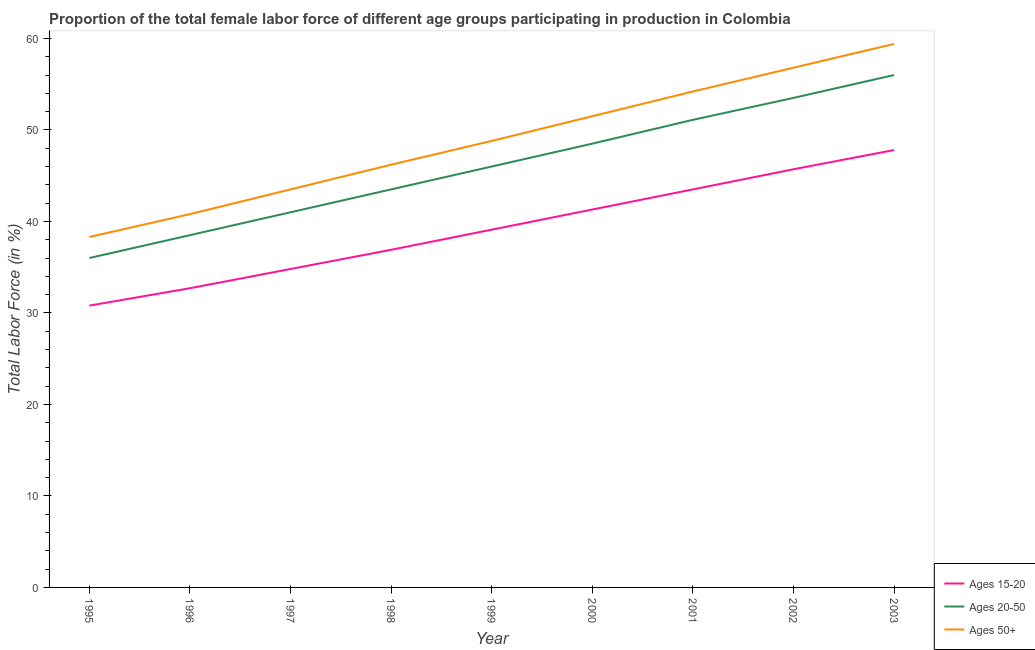How many different coloured lines are there?
Make the answer very short. 3. Is the number of lines equal to the number of legend labels?
Your answer should be compact. Yes. What is the percentage of female labor force within the age group 15-20 in 2001?
Offer a very short reply. 43.5. Across all years, what is the maximum percentage of female labor force within the age group 15-20?
Keep it short and to the point. 47.8. Across all years, what is the minimum percentage of female labor force within the age group 15-20?
Keep it short and to the point. 30.8. What is the total percentage of female labor force within the age group 15-20 in the graph?
Give a very brief answer. 352.6. What is the difference between the percentage of female labor force within the age group 20-50 in 1995 and that in 2003?
Provide a succinct answer. -20. What is the difference between the percentage of female labor force within the age group 20-50 in 1997 and the percentage of female labor force within the age group 15-20 in 1998?
Your answer should be compact. 4.1. What is the average percentage of female labor force within the age group 15-20 per year?
Provide a short and direct response. 39.18. In the year 2001, what is the difference between the percentage of female labor force within the age group 20-50 and percentage of female labor force within the age group 15-20?
Provide a short and direct response. 7.6. What is the ratio of the percentage of female labor force within the age group 20-50 in 1996 to that in 2001?
Make the answer very short. 0.75. Is the percentage of female labor force within the age group 20-50 in 1997 less than that in 1999?
Give a very brief answer. Yes. Is the difference between the percentage of female labor force above age 50 in 1997 and 2003 greater than the difference between the percentage of female labor force within the age group 15-20 in 1997 and 2003?
Your answer should be very brief. No. What is the difference between the highest and the lowest percentage of female labor force within the age group 15-20?
Ensure brevity in your answer.  17. Is it the case that in every year, the sum of the percentage of female labor force within the age group 15-20 and percentage of female labor force within the age group 20-50 is greater than the percentage of female labor force above age 50?
Keep it short and to the point. Yes. Does the percentage of female labor force within the age group 20-50 monotonically increase over the years?
Provide a short and direct response. Yes. Is the percentage of female labor force within the age group 15-20 strictly less than the percentage of female labor force above age 50 over the years?
Offer a terse response. Yes. How many lines are there?
Your answer should be compact. 3. How many years are there in the graph?
Keep it short and to the point. 9. What is the difference between two consecutive major ticks on the Y-axis?
Your answer should be compact. 10. Are the values on the major ticks of Y-axis written in scientific E-notation?
Offer a terse response. No. Where does the legend appear in the graph?
Provide a short and direct response. Bottom right. How are the legend labels stacked?
Offer a terse response. Vertical. What is the title of the graph?
Ensure brevity in your answer.  Proportion of the total female labor force of different age groups participating in production in Colombia. What is the label or title of the Y-axis?
Provide a succinct answer. Total Labor Force (in %). What is the Total Labor Force (in %) of Ages 15-20 in 1995?
Keep it short and to the point. 30.8. What is the Total Labor Force (in %) in Ages 20-50 in 1995?
Offer a terse response. 36. What is the Total Labor Force (in %) of Ages 50+ in 1995?
Provide a short and direct response. 38.3. What is the Total Labor Force (in %) of Ages 15-20 in 1996?
Your response must be concise. 32.7. What is the Total Labor Force (in %) in Ages 20-50 in 1996?
Give a very brief answer. 38.5. What is the Total Labor Force (in %) in Ages 50+ in 1996?
Your response must be concise. 40.8. What is the Total Labor Force (in %) in Ages 15-20 in 1997?
Your answer should be very brief. 34.8. What is the Total Labor Force (in %) of Ages 20-50 in 1997?
Provide a succinct answer. 41. What is the Total Labor Force (in %) in Ages 50+ in 1997?
Your answer should be very brief. 43.5. What is the Total Labor Force (in %) of Ages 15-20 in 1998?
Provide a succinct answer. 36.9. What is the Total Labor Force (in %) of Ages 20-50 in 1998?
Ensure brevity in your answer.  43.5. What is the Total Labor Force (in %) in Ages 50+ in 1998?
Give a very brief answer. 46.2. What is the Total Labor Force (in %) in Ages 15-20 in 1999?
Ensure brevity in your answer.  39.1. What is the Total Labor Force (in %) of Ages 20-50 in 1999?
Give a very brief answer. 46. What is the Total Labor Force (in %) of Ages 50+ in 1999?
Make the answer very short. 48.8. What is the Total Labor Force (in %) in Ages 15-20 in 2000?
Your answer should be very brief. 41.3. What is the Total Labor Force (in %) in Ages 20-50 in 2000?
Make the answer very short. 48.5. What is the Total Labor Force (in %) of Ages 50+ in 2000?
Make the answer very short. 51.5. What is the Total Labor Force (in %) of Ages 15-20 in 2001?
Your answer should be very brief. 43.5. What is the Total Labor Force (in %) in Ages 20-50 in 2001?
Provide a succinct answer. 51.1. What is the Total Labor Force (in %) in Ages 50+ in 2001?
Your answer should be very brief. 54.2. What is the Total Labor Force (in %) of Ages 15-20 in 2002?
Offer a terse response. 45.7. What is the Total Labor Force (in %) in Ages 20-50 in 2002?
Your answer should be compact. 53.5. What is the Total Labor Force (in %) of Ages 50+ in 2002?
Your response must be concise. 56.8. What is the Total Labor Force (in %) in Ages 15-20 in 2003?
Your answer should be very brief. 47.8. What is the Total Labor Force (in %) of Ages 20-50 in 2003?
Keep it short and to the point. 56. What is the Total Labor Force (in %) in Ages 50+ in 2003?
Make the answer very short. 59.4. Across all years, what is the maximum Total Labor Force (in %) in Ages 15-20?
Your answer should be very brief. 47.8. Across all years, what is the maximum Total Labor Force (in %) of Ages 50+?
Keep it short and to the point. 59.4. Across all years, what is the minimum Total Labor Force (in %) in Ages 15-20?
Make the answer very short. 30.8. Across all years, what is the minimum Total Labor Force (in %) of Ages 50+?
Offer a terse response. 38.3. What is the total Total Labor Force (in %) in Ages 15-20 in the graph?
Your response must be concise. 352.6. What is the total Total Labor Force (in %) of Ages 20-50 in the graph?
Your response must be concise. 414.1. What is the total Total Labor Force (in %) of Ages 50+ in the graph?
Offer a very short reply. 439.5. What is the difference between the Total Labor Force (in %) in Ages 15-20 in 1995 and that in 1996?
Give a very brief answer. -1.9. What is the difference between the Total Labor Force (in %) of Ages 20-50 in 1995 and that in 1996?
Your answer should be compact. -2.5. What is the difference between the Total Labor Force (in %) of Ages 20-50 in 1995 and that in 1997?
Your answer should be very brief. -5. What is the difference between the Total Labor Force (in %) in Ages 20-50 in 1995 and that in 2001?
Provide a succinct answer. -15.1. What is the difference between the Total Labor Force (in %) of Ages 50+ in 1995 and that in 2001?
Give a very brief answer. -15.9. What is the difference between the Total Labor Force (in %) in Ages 15-20 in 1995 and that in 2002?
Keep it short and to the point. -14.9. What is the difference between the Total Labor Force (in %) in Ages 20-50 in 1995 and that in 2002?
Make the answer very short. -17.5. What is the difference between the Total Labor Force (in %) in Ages 50+ in 1995 and that in 2002?
Give a very brief answer. -18.5. What is the difference between the Total Labor Force (in %) in Ages 20-50 in 1995 and that in 2003?
Your answer should be very brief. -20. What is the difference between the Total Labor Force (in %) of Ages 50+ in 1995 and that in 2003?
Your response must be concise. -21.1. What is the difference between the Total Labor Force (in %) of Ages 15-20 in 1996 and that in 1997?
Offer a terse response. -2.1. What is the difference between the Total Labor Force (in %) of Ages 50+ in 1996 and that in 1997?
Offer a terse response. -2.7. What is the difference between the Total Labor Force (in %) in Ages 15-20 in 1996 and that in 1998?
Offer a terse response. -4.2. What is the difference between the Total Labor Force (in %) of Ages 50+ in 1996 and that in 1998?
Give a very brief answer. -5.4. What is the difference between the Total Labor Force (in %) of Ages 20-50 in 1996 and that in 1999?
Make the answer very short. -7.5. What is the difference between the Total Labor Force (in %) in Ages 15-20 in 1996 and that in 2000?
Your response must be concise. -8.6. What is the difference between the Total Labor Force (in %) of Ages 50+ in 1996 and that in 2000?
Give a very brief answer. -10.7. What is the difference between the Total Labor Force (in %) in Ages 15-20 in 1996 and that in 2002?
Keep it short and to the point. -13. What is the difference between the Total Labor Force (in %) in Ages 15-20 in 1996 and that in 2003?
Your answer should be very brief. -15.1. What is the difference between the Total Labor Force (in %) of Ages 20-50 in 1996 and that in 2003?
Your answer should be compact. -17.5. What is the difference between the Total Labor Force (in %) in Ages 50+ in 1996 and that in 2003?
Your answer should be compact. -18.6. What is the difference between the Total Labor Force (in %) in Ages 20-50 in 1997 and that in 1998?
Ensure brevity in your answer.  -2.5. What is the difference between the Total Labor Force (in %) of Ages 50+ in 1997 and that in 1998?
Your response must be concise. -2.7. What is the difference between the Total Labor Force (in %) of Ages 20-50 in 1997 and that in 1999?
Provide a succinct answer. -5. What is the difference between the Total Labor Force (in %) in Ages 15-20 in 1997 and that in 2001?
Provide a succinct answer. -8.7. What is the difference between the Total Labor Force (in %) of Ages 20-50 in 1997 and that in 2001?
Ensure brevity in your answer.  -10.1. What is the difference between the Total Labor Force (in %) in Ages 15-20 in 1997 and that in 2002?
Keep it short and to the point. -10.9. What is the difference between the Total Labor Force (in %) in Ages 20-50 in 1997 and that in 2002?
Keep it short and to the point. -12.5. What is the difference between the Total Labor Force (in %) of Ages 50+ in 1997 and that in 2002?
Your answer should be very brief. -13.3. What is the difference between the Total Labor Force (in %) of Ages 20-50 in 1997 and that in 2003?
Ensure brevity in your answer.  -15. What is the difference between the Total Labor Force (in %) of Ages 50+ in 1997 and that in 2003?
Ensure brevity in your answer.  -15.9. What is the difference between the Total Labor Force (in %) of Ages 15-20 in 1998 and that in 1999?
Provide a short and direct response. -2.2. What is the difference between the Total Labor Force (in %) in Ages 50+ in 1998 and that in 1999?
Give a very brief answer. -2.6. What is the difference between the Total Labor Force (in %) of Ages 15-20 in 1998 and that in 2000?
Your response must be concise. -4.4. What is the difference between the Total Labor Force (in %) of Ages 20-50 in 1998 and that in 2000?
Offer a very short reply. -5. What is the difference between the Total Labor Force (in %) of Ages 50+ in 1998 and that in 2001?
Offer a terse response. -8. What is the difference between the Total Labor Force (in %) of Ages 20-50 in 1998 and that in 2002?
Give a very brief answer. -10. What is the difference between the Total Labor Force (in %) in Ages 15-20 in 1998 and that in 2003?
Your answer should be compact. -10.9. What is the difference between the Total Labor Force (in %) in Ages 20-50 in 1998 and that in 2003?
Offer a terse response. -12.5. What is the difference between the Total Labor Force (in %) of Ages 15-20 in 1999 and that in 2000?
Ensure brevity in your answer.  -2.2. What is the difference between the Total Labor Force (in %) of Ages 50+ in 1999 and that in 2001?
Your answer should be compact. -5.4. What is the difference between the Total Labor Force (in %) in Ages 15-20 in 1999 and that in 2002?
Ensure brevity in your answer.  -6.6. What is the difference between the Total Labor Force (in %) of Ages 20-50 in 1999 and that in 2002?
Keep it short and to the point. -7.5. What is the difference between the Total Labor Force (in %) in Ages 50+ in 1999 and that in 2002?
Give a very brief answer. -8. What is the difference between the Total Labor Force (in %) of Ages 15-20 in 1999 and that in 2003?
Your answer should be compact. -8.7. What is the difference between the Total Labor Force (in %) in Ages 20-50 in 1999 and that in 2003?
Your answer should be very brief. -10. What is the difference between the Total Labor Force (in %) in Ages 50+ in 1999 and that in 2003?
Offer a very short reply. -10.6. What is the difference between the Total Labor Force (in %) in Ages 15-20 in 2000 and that in 2001?
Keep it short and to the point. -2.2. What is the difference between the Total Labor Force (in %) in Ages 50+ in 2000 and that in 2001?
Offer a terse response. -2.7. What is the difference between the Total Labor Force (in %) in Ages 20-50 in 2000 and that in 2002?
Offer a very short reply. -5. What is the difference between the Total Labor Force (in %) in Ages 15-20 in 2000 and that in 2003?
Ensure brevity in your answer.  -6.5. What is the difference between the Total Labor Force (in %) of Ages 50+ in 2000 and that in 2003?
Provide a succinct answer. -7.9. What is the difference between the Total Labor Force (in %) in Ages 15-20 in 2001 and that in 2002?
Your answer should be compact. -2.2. What is the difference between the Total Labor Force (in %) of Ages 15-20 in 2001 and that in 2003?
Keep it short and to the point. -4.3. What is the difference between the Total Labor Force (in %) in Ages 15-20 in 2002 and that in 2003?
Ensure brevity in your answer.  -2.1. What is the difference between the Total Labor Force (in %) of Ages 50+ in 2002 and that in 2003?
Provide a succinct answer. -2.6. What is the difference between the Total Labor Force (in %) in Ages 15-20 in 1995 and the Total Labor Force (in %) in Ages 20-50 in 1996?
Make the answer very short. -7.7. What is the difference between the Total Labor Force (in %) of Ages 20-50 in 1995 and the Total Labor Force (in %) of Ages 50+ in 1996?
Your answer should be very brief. -4.8. What is the difference between the Total Labor Force (in %) of Ages 15-20 in 1995 and the Total Labor Force (in %) of Ages 20-50 in 1997?
Your answer should be compact. -10.2. What is the difference between the Total Labor Force (in %) in Ages 15-20 in 1995 and the Total Labor Force (in %) in Ages 50+ in 1997?
Offer a very short reply. -12.7. What is the difference between the Total Labor Force (in %) of Ages 15-20 in 1995 and the Total Labor Force (in %) of Ages 20-50 in 1998?
Your answer should be very brief. -12.7. What is the difference between the Total Labor Force (in %) of Ages 15-20 in 1995 and the Total Labor Force (in %) of Ages 50+ in 1998?
Give a very brief answer. -15.4. What is the difference between the Total Labor Force (in %) in Ages 20-50 in 1995 and the Total Labor Force (in %) in Ages 50+ in 1998?
Offer a very short reply. -10.2. What is the difference between the Total Labor Force (in %) in Ages 15-20 in 1995 and the Total Labor Force (in %) in Ages 20-50 in 1999?
Provide a short and direct response. -15.2. What is the difference between the Total Labor Force (in %) of Ages 15-20 in 1995 and the Total Labor Force (in %) of Ages 20-50 in 2000?
Keep it short and to the point. -17.7. What is the difference between the Total Labor Force (in %) of Ages 15-20 in 1995 and the Total Labor Force (in %) of Ages 50+ in 2000?
Your response must be concise. -20.7. What is the difference between the Total Labor Force (in %) in Ages 20-50 in 1995 and the Total Labor Force (in %) in Ages 50+ in 2000?
Offer a very short reply. -15.5. What is the difference between the Total Labor Force (in %) in Ages 15-20 in 1995 and the Total Labor Force (in %) in Ages 20-50 in 2001?
Your response must be concise. -20.3. What is the difference between the Total Labor Force (in %) in Ages 15-20 in 1995 and the Total Labor Force (in %) in Ages 50+ in 2001?
Provide a succinct answer. -23.4. What is the difference between the Total Labor Force (in %) of Ages 20-50 in 1995 and the Total Labor Force (in %) of Ages 50+ in 2001?
Offer a very short reply. -18.2. What is the difference between the Total Labor Force (in %) of Ages 15-20 in 1995 and the Total Labor Force (in %) of Ages 20-50 in 2002?
Make the answer very short. -22.7. What is the difference between the Total Labor Force (in %) of Ages 20-50 in 1995 and the Total Labor Force (in %) of Ages 50+ in 2002?
Your answer should be very brief. -20.8. What is the difference between the Total Labor Force (in %) in Ages 15-20 in 1995 and the Total Labor Force (in %) in Ages 20-50 in 2003?
Give a very brief answer. -25.2. What is the difference between the Total Labor Force (in %) in Ages 15-20 in 1995 and the Total Labor Force (in %) in Ages 50+ in 2003?
Ensure brevity in your answer.  -28.6. What is the difference between the Total Labor Force (in %) in Ages 20-50 in 1995 and the Total Labor Force (in %) in Ages 50+ in 2003?
Keep it short and to the point. -23.4. What is the difference between the Total Labor Force (in %) in Ages 15-20 in 1996 and the Total Labor Force (in %) in Ages 20-50 in 1997?
Offer a very short reply. -8.3. What is the difference between the Total Labor Force (in %) in Ages 15-20 in 1996 and the Total Labor Force (in %) in Ages 50+ in 1997?
Your answer should be very brief. -10.8. What is the difference between the Total Labor Force (in %) of Ages 20-50 in 1996 and the Total Labor Force (in %) of Ages 50+ in 1997?
Offer a very short reply. -5. What is the difference between the Total Labor Force (in %) in Ages 20-50 in 1996 and the Total Labor Force (in %) in Ages 50+ in 1998?
Ensure brevity in your answer.  -7.7. What is the difference between the Total Labor Force (in %) in Ages 15-20 in 1996 and the Total Labor Force (in %) in Ages 50+ in 1999?
Ensure brevity in your answer.  -16.1. What is the difference between the Total Labor Force (in %) in Ages 20-50 in 1996 and the Total Labor Force (in %) in Ages 50+ in 1999?
Your answer should be very brief. -10.3. What is the difference between the Total Labor Force (in %) of Ages 15-20 in 1996 and the Total Labor Force (in %) of Ages 20-50 in 2000?
Offer a very short reply. -15.8. What is the difference between the Total Labor Force (in %) of Ages 15-20 in 1996 and the Total Labor Force (in %) of Ages 50+ in 2000?
Give a very brief answer. -18.8. What is the difference between the Total Labor Force (in %) in Ages 20-50 in 1996 and the Total Labor Force (in %) in Ages 50+ in 2000?
Provide a succinct answer. -13. What is the difference between the Total Labor Force (in %) of Ages 15-20 in 1996 and the Total Labor Force (in %) of Ages 20-50 in 2001?
Provide a short and direct response. -18.4. What is the difference between the Total Labor Force (in %) of Ages 15-20 in 1996 and the Total Labor Force (in %) of Ages 50+ in 2001?
Keep it short and to the point. -21.5. What is the difference between the Total Labor Force (in %) of Ages 20-50 in 1996 and the Total Labor Force (in %) of Ages 50+ in 2001?
Give a very brief answer. -15.7. What is the difference between the Total Labor Force (in %) of Ages 15-20 in 1996 and the Total Labor Force (in %) of Ages 20-50 in 2002?
Give a very brief answer. -20.8. What is the difference between the Total Labor Force (in %) of Ages 15-20 in 1996 and the Total Labor Force (in %) of Ages 50+ in 2002?
Ensure brevity in your answer.  -24.1. What is the difference between the Total Labor Force (in %) of Ages 20-50 in 1996 and the Total Labor Force (in %) of Ages 50+ in 2002?
Your response must be concise. -18.3. What is the difference between the Total Labor Force (in %) in Ages 15-20 in 1996 and the Total Labor Force (in %) in Ages 20-50 in 2003?
Provide a succinct answer. -23.3. What is the difference between the Total Labor Force (in %) of Ages 15-20 in 1996 and the Total Labor Force (in %) of Ages 50+ in 2003?
Offer a terse response. -26.7. What is the difference between the Total Labor Force (in %) of Ages 20-50 in 1996 and the Total Labor Force (in %) of Ages 50+ in 2003?
Offer a terse response. -20.9. What is the difference between the Total Labor Force (in %) of Ages 15-20 in 1997 and the Total Labor Force (in %) of Ages 20-50 in 1999?
Your answer should be compact. -11.2. What is the difference between the Total Labor Force (in %) in Ages 15-20 in 1997 and the Total Labor Force (in %) in Ages 50+ in 1999?
Your answer should be very brief. -14. What is the difference between the Total Labor Force (in %) in Ages 20-50 in 1997 and the Total Labor Force (in %) in Ages 50+ in 1999?
Your answer should be very brief. -7.8. What is the difference between the Total Labor Force (in %) in Ages 15-20 in 1997 and the Total Labor Force (in %) in Ages 20-50 in 2000?
Provide a succinct answer. -13.7. What is the difference between the Total Labor Force (in %) of Ages 15-20 in 1997 and the Total Labor Force (in %) of Ages 50+ in 2000?
Your answer should be very brief. -16.7. What is the difference between the Total Labor Force (in %) of Ages 20-50 in 1997 and the Total Labor Force (in %) of Ages 50+ in 2000?
Offer a terse response. -10.5. What is the difference between the Total Labor Force (in %) in Ages 15-20 in 1997 and the Total Labor Force (in %) in Ages 20-50 in 2001?
Provide a short and direct response. -16.3. What is the difference between the Total Labor Force (in %) in Ages 15-20 in 1997 and the Total Labor Force (in %) in Ages 50+ in 2001?
Offer a terse response. -19.4. What is the difference between the Total Labor Force (in %) of Ages 15-20 in 1997 and the Total Labor Force (in %) of Ages 20-50 in 2002?
Your answer should be very brief. -18.7. What is the difference between the Total Labor Force (in %) of Ages 20-50 in 1997 and the Total Labor Force (in %) of Ages 50+ in 2002?
Provide a succinct answer. -15.8. What is the difference between the Total Labor Force (in %) of Ages 15-20 in 1997 and the Total Labor Force (in %) of Ages 20-50 in 2003?
Give a very brief answer. -21.2. What is the difference between the Total Labor Force (in %) in Ages 15-20 in 1997 and the Total Labor Force (in %) in Ages 50+ in 2003?
Ensure brevity in your answer.  -24.6. What is the difference between the Total Labor Force (in %) in Ages 20-50 in 1997 and the Total Labor Force (in %) in Ages 50+ in 2003?
Give a very brief answer. -18.4. What is the difference between the Total Labor Force (in %) in Ages 15-20 in 1998 and the Total Labor Force (in %) in Ages 20-50 in 1999?
Ensure brevity in your answer.  -9.1. What is the difference between the Total Labor Force (in %) of Ages 15-20 in 1998 and the Total Labor Force (in %) of Ages 50+ in 1999?
Your answer should be very brief. -11.9. What is the difference between the Total Labor Force (in %) of Ages 15-20 in 1998 and the Total Labor Force (in %) of Ages 50+ in 2000?
Give a very brief answer. -14.6. What is the difference between the Total Labor Force (in %) in Ages 15-20 in 1998 and the Total Labor Force (in %) in Ages 50+ in 2001?
Your response must be concise. -17.3. What is the difference between the Total Labor Force (in %) in Ages 20-50 in 1998 and the Total Labor Force (in %) in Ages 50+ in 2001?
Offer a very short reply. -10.7. What is the difference between the Total Labor Force (in %) in Ages 15-20 in 1998 and the Total Labor Force (in %) in Ages 20-50 in 2002?
Keep it short and to the point. -16.6. What is the difference between the Total Labor Force (in %) of Ages 15-20 in 1998 and the Total Labor Force (in %) of Ages 50+ in 2002?
Your answer should be compact. -19.9. What is the difference between the Total Labor Force (in %) in Ages 20-50 in 1998 and the Total Labor Force (in %) in Ages 50+ in 2002?
Offer a terse response. -13.3. What is the difference between the Total Labor Force (in %) in Ages 15-20 in 1998 and the Total Labor Force (in %) in Ages 20-50 in 2003?
Provide a succinct answer. -19.1. What is the difference between the Total Labor Force (in %) of Ages 15-20 in 1998 and the Total Labor Force (in %) of Ages 50+ in 2003?
Keep it short and to the point. -22.5. What is the difference between the Total Labor Force (in %) in Ages 20-50 in 1998 and the Total Labor Force (in %) in Ages 50+ in 2003?
Your answer should be compact. -15.9. What is the difference between the Total Labor Force (in %) of Ages 15-20 in 1999 and the Total Labor Force (in %) of Ages 20-50 in 2001?
Provide a succinct answer. -12. What is the difference between the Total Labor Force (in %) in Ages 15-20 in 1999 and the Total Labor Force (in %) in Ages 50+ in 2001?
Your response must be concise. -15.1. What is the difference between the Total Labor Force (in %) in Ages 15-20 in 1999 and the Total Labor Force (in %) in Ages 20-50 in 2002?
Give a very brief answer. -14.4. What is the difference between the Total Labor Force (in %) of Ages 15-20 in 1999 and the Total Labor Force (in %) of Ages 50+ in 2002?
Keep it short and to the point. -17.7. What is the difference between the Total Labor Force (in %) of Ages 20-50 in 1999 and the Total Labor Force (in %) of Ages 50+ in 2002?
Make the answer very short. -10.8. What is the difference between the Total Labor Force (in %) of Ages 15-20 in 1999 and the Total Labor Force (in %) of Ages 20-50 in 2003?
Make the answer very short. -16.9. What is the difference between the Total Labor Force (in %) in Ages 15-20 in 1999 and the Total Labor Force (in %) in Ages 50+ in 2003?
Keep it short and to the point. -20.3. What is the difference between the Total Labor Force (in %) of Ages 15-20 in 2000 and the Total Labor Force (in %) of Ages 50+ in 2002?
Offer a very short reply. -15.5. What is the difference between the Total Labor Force (in %) in Ages 15-20 in 2000 and the Total Labor Force (in %) in Ages 20-50 in 2003?
Offer a terse response. -14.7. What is the difference between the Total Labor Force (in %) of Ages 15-20 in 2000 and the Total Labor Force (in %) of Ages 50+ in 2003?
Your response must be concise. -18.1. What is the difference between the Total Labor Force (in %) of Ages 15-20 in 2001 and the Total Labor Force (in %) of Ages 50+ in 2002?
Keep it short and to the point. -13.3. What is the difference between the Total Labor Force (in %) in Ages 20-50 in 2001 and the Total Labor Force (in %) in Ages 50+ in 2002?
Provide a short and direct response. -5.7. What is the difference between the Total Labor Force (in %) in Ages 15-20 in 2001 and the Total Labor Force (in %) in Ages 20-50 in 2003?
Your response must be concise. -12.5. What is the difference between the Total Labor Force (in %) in Ages 15-20 in 2001 and the Total Labor Force (in %) in Ages 50+ in 2003?
Ensure brevity in your answer.  -15.9. What is the difference between the Total Labor Force (in %) in Ages 20-50 in 2001 and the Total Labor Force (in %) in Ages 50+ in 2003?
Ensure brevity in your answer.  -8.3. What is the difference between the Total Labor Force (in %) of Ages 15-20 in 2002 and the Total Labor Force (in %) of Ages 50+ in 2003?
Keep it short and to the point. -13.7. What is the difference between the Total Labor Force (in %) of Ages 20-50 in 2002 and the Total Labor Force (in %) of Ages 50+ in 2003?
Provide a short and direct response. -5.9. What is the average Total Labor Force (in %) of Ages 15-20 per year?
Your answer should be very brief. 39.18. What is the average Total Labor Force (in %) of Ages 20-50 per year?
Ensure brevity in your answer.  46.01. What is the average Total Labor Force (in %) of Ages 50+ per year?
Offer a terse response. 48.83. In the year 1996, what is the difference between the Total Labor Force (in %) of Ages 20-50 and Total Labor Force (in %) of Ages 50+?
Your response must be concise. -2.3. In the year 1997, what is the difference between the Total Labor Force (in %) in Ages 15-20 and Total Labor Force (in %) in Ages 20-50?
Keep it short and to the point. -6.2. In the year 1997, what is the difference between the Total Labor Force (in %) in Ages 20-50 and Total Labor Force (in %) in Ages 50+?
Ensure brevity in your answer.  -2.5. In the year 1998, what is the difference between the Total Labor Force (in %) in Ages 15-20 and Total Labor Force (in %) in Ages 50+?
Provide a short and direct response. -9.3. In the year 1998, what is the difference between the Total Labor Force (in %) of Ages 20-50 and Total Labor Force (in %) of Ages 50+?
Provide a short and direct response. -2.7. In the year 1999, what is the difference between the Total Labor Force (in %) of Ages 15-20 and Total Labor Force (in %) of Ages 20-50?
Your response must be concise. -6.9. In the year 1999, what is the difference between the Total Labor Force (in %) of Ages 15-20 and Total Labor Force (in %) of Ages 50+?
Offer a very short reply. -9.7. In the year 1999, what is the difference between the Total Labor Force (in %) of Ages 20-50 and Total Labor Force (in %) of Ages 50+?
Offer a very short reply. -2.8. In the year 2000, what is the difference between the Total Labor Force (in %) in Ages 15-20 and Total Labor Force (in %) in Ages 20-50?
Offer a terse response. -7.2. In the year 2001, what is the difference between the Total Labor Force (in %) in Ages 15-20 and Total Labor Force (in %) in Ages 50+?
Give a very brief answer. -10.7. In the year 2002, what is the difference between the Total Labor Force (in %) in Ages 15-20 and Total Labor Force (in %) in Ages 20-50?
Your answer should be very brief. -7.8. In the year 2002, what is the difference between the Total Labor Force (in %) of Ages 15-20 and Total Labor Force (in %) of Ages 50+?
Offer a terse response. -11.1. In the year 2003, what is the difference between the Total Labor Force (in %) of Ages 15-20 and Total Labor Force (in %) of Ages 20-50?
Ensure brevity in your answer.  -8.2. In the year 2003, what is the difference between the Total Labor Force (in %) in Ages 15-20 and Total Labor Force (in %) in Ages 50+?
Provide a succinct answer. -11.6. In the year 2003, what is the difference between the Total Labor Force (in %) of Ages 20-50 and Total Labor Force (in %) of Ages 50+?
Ensure brevity in your answer.  -3.4. What is the ratio of the Total Labor Force (in %) of Ages 15-20 in 1995 to that in 1996?
Ensure brevity in your answer.  0.94. What is the ratio of the Total Labor Force (in %) of Ages 20-50 in 1995 to that in 1996?
Provide a succinct answer. 0.94. What is the ratio of the Total Labor Force (in %) in Ages 50+ in 1995 to that in 1996?
Your response must be concise. 0.94. What is the ratio of the Total Labor Force (in %) in Ages 15-20 in 1995 to that in 1997?
Your response must be concise. 0.89. What is the ratio of the Total Labor Force (in %) of Ages 20-50 in 1995 to that in 1997?
Your response must be concise. 0.88. What is the ratio of the Total Labor Force (in %) of Ages 50+ in 1995 to that in 1997?
Your answer should be very brief. 0.88. What is the ratio of the Total Labor Force (in %) in Ages 15-20 in 1995 to that in 1998?
Your response must be concise. 0.83. What is the ratio of the Total Labor Force (in %) of Ages 20-50 in 1995 to that in 1998?
Keep it short and to the point. 0.83. What is the ratio of the Total Labor Force (in %) in Ages 50+ in 1995 to that in 1998?
Your response must be concise. 0.83. What is the ratio of the Total Labor Force (in %) in Ages 15-20 in 1995 to that in 1999?
Make the answer very short. 0.79. What is the ratio of the Total Labor Force (in %) of Ages 20-50 in 1995 to that in 1999?
Give a very brief answer. 0.78. What is the ratio of the Total Labor Force (in %) of Ages 50+ in 1995 to that in 1999?
Ensure brevity in your answer.  0.78. What is the ratio of the Total Labor Force (in %) in Ages 15-20 in 1995 to that in 2000?
Provide a succinct answer. 0.75. What is the ratio of the Total Labor Force (in %) in Ages 20-50 in 1995 to that in 2000?
Provide a short and direct response. 0.74. What is the ratio of the Total Labor Force (in %) of Ages 50+ in 1995 to that in 2000?
Your answer should be compact. 0.74. What is the ratio of the Total Labor Force (in %) of Ages 15-20 in 1995 to that in 2001?
Keep it short and to the point. 0.71. What is the ratio of the Total Labor Force (in %) in Ages 20-50 in 1995 to that in 2001?
Keep it short and to the point. 0.7. What is the ratio of the Total Labor Force (in %) of Ages 50+ in 1995 to that in 2001?
Your answer should be very brief. 0.71. What is the ratio of the Total Labor Force (in %) in Ages 15-20 in 1995 to that in 2002?
Your answer should be very brief. 0.67. What is the ratio of the Total Labor Force (in %) of Ages 20-50 in 1995 to that in 2002?
Your response must be concise. 0.67. What is the ratio of the Total Labor Force (in %) in Ages 50+ in 1995 to that in 2002?
Provide a short and direct response. 0.67. What is the ratio of the Total Labor Force (in %) of Ages 15-20 in 1995 to that in 2003?
Offer a terse response. 0.64. What is the ratio of the Total Labor Force (in %) of Ages 20-50 in 1995 to that in 2003?
Your answer should be compact. 0.64. What is the ratio of the Total Labor Force (in %) of Ages 50+ in 1995 to that in 2003?
Provide a succinct answer. 0.64. What is the ratio of the Total Labor Force (in %) in Ages 15-20 in 1996 to that in 1997?
Ensure brevity in your answer.  0.94. What is the ratio of the Total Labor Force (in %) of Ages 20-50 in 1996 to that in 1997?
Your answer should be compact. 0.94. What is the ratio of the Total Labor Force (in %) of Ages 50+ in 1996 to that in 1997?
Keep it short and to the point. 0.94. What is the ratio of the Total Labor Force (in %) in Ages 15-20 in 1996 to that in 1998?
Your answer should be compact. 0.89. What is the ratio of the Total Labor Force (in %) of Ages 20-50 in 1996 to that in 1998?
Your response must be concise. 0.89. What is the ratio of the Total Labor Force (in %) of Ages 50+ in 1996 to that in 1998?
Provide a short and direct response. 0.88. What is the ratio of the Total Labor Force (in %) in Ages 15-20 in 1996 to that in 1999?
Make the answer very short. 0.84. What is the ratio of the Total Labor Force (in %) in Ages 20-50 in 1996 to that in 1999?
Give a very brief answer. 0.84. What is the ratio of the Total Labor Force (in %) of Ages 50+ in 1996 to that in 1999?
Give a very brief answer. 0.84. What is the ratio of the Total Labor Force (in %) of Ages 15-20 in 1996 to that in 2000?
Offer a very short reply. 0.79. What is the ratio of the Total Labor Force (in %) in Ages 20-50 in 1996 to that in 2000?
Provide a short and direct response. 0.79. What is the ratio of the Total Labor Force (in %) of Ages 50+ in 1996 to that in 2000?
Provide a short and direct response. 0.79. What is the ratio of the Total Labor Force (in %) in Ages 15-20 in 1996 to that in 2001?
Give a very brief answer. 0.75. What is the ratio of the Total Labor Force (in %) of Ages 20-50 in 1996 to that in 2001?
Ensure brevity in your answer.  0.75. What is the ratio of the Total Labor Force (in %) of Ages 50+ in 1996 to that in 2001?
Provide a succinct answer. 0.75. What is the ratio of the Total Labor Force (in %) in Ages 15-20 in 1996 to that in 2002?
Your answer should be compact. 0.72. What is the ratio of the Total Labor Force (in %) in Ages 20-50 in 1996 to that in 2002?
Offer a terse response. 0.72. What is the ratio of the Total Labor Force (in %) in Ages 50+ in 1996 to that in 2002?
Offer a terse response. 0.72. What is the ratio of the Total Labor Force (in %) of Ages 15-20 in 1996 to that in 2003?
Provide a succinct answer. 0.68. What is the ratio of the Total Labor Force (in %) in Ages 20-50 in 1996 to that in 2003?
Provide a short and direct response. 0.69. What is the ratio of the Total Labor Force (in %) in Ages 50+ in 1996 to that in 2003?
Offer a terse response. 0.69. What is the ratio of the Total Labor Force (in %) in Ages 15-20 in 1997 to that in 1998?
Make the answer very short. 0.94. What is the ratio of the Total Labor Force (in %) of Ages 20-50 in 1997 to that in 1998?
Ensure brevity in your answer.  0.94. What is the ratio of the Total Labor Force (in %) of Ages 50+ in 1997 to that in 1998?
Provide a succinct answer. 0.94. What is the ratio of the Total Labor Force (in %) in Ages 15-20 in 1997 to that in 1999?
Ensure brevity in your answer.  0.89. What is the ratio of the Total Labor Force (in %) of Ages 20-50 in 1997 to that in 1999?
Provide a short and direct response. 0.89. What is the ratio of the Total Labor Force (in %) in Ages 50+ in 1997 to that in 1999?
Offer a terse response. 0.89. What is the ratio of the Total Labor Force (in %) in Ages 15-20 in 1997 to that in 2000?
Your answer should be compact. 0.84. What is the ratio of the Total Labor Force (in %) of Ages 20-50 in 1997 to that in 2000?
Make the answer very short. 0.85. What is the ratio of the Total Labor Force (in %) in Ages 50+ in 1997 to that in 2000?
Your response must be concise. 0.84. What is the ratio of the Total Labor Force (in %) of Ages 15-20 in 1997 to that in 2001?
Your answer should be compact. 0.8. What is the ratio of the Total Labor Force (in %) of Ages 20-50 in 1997 to that in 2001?
Your response must be concise. 0.8. What is the ratio of the Total Labor Force (in %) of Ages 50+ in 1997 to that in 2001?
Your answer should be compact. 0.8. What is the ratio of the Total Labor Force (in %) in Ages 15-20 in 1997 to that in 2002?
Offer a terse response. 0.76. What is the ratio of the Total Labor Force (in %) in Ages 20-50 in 1997 to that in 2002?
Your response must be concise. 0.77. What is the ratio of the Total Labor Force (in %) in Ages 50+ in 1997 to that in 2002?
Offer a terse response. 0.77. What is the ratio of the Total Labor Force (in %) in Ages 15-20 in 1997 to that in 2003?
Make the answer very short. 0.73. What is the ratio of the Total Labor Force (in %) in Ages 20-50 in 1997 to that in 2003?
Your answer should be compact. 0.73. What is the ratio of the Total Labor Force (in %) in Ages 50+ in 1997 to that in 2003?
Your answer should be very brief. 0.73. What is the ratio of the Total Labor Force (in %) of Ages 15-20 in 1998 to that in 1999?
Your answer should be very brief. 0.94. What is the ratio of the Total Labor Force (in %) of Ages 20-50 in 1998 to that in 1999?
Give a very brief answer. 0.95. What is the ratio of the Total Labor Force (in %) in Ages 50+ in 1998 to that in 1999?
Offer a very short reply. 0.95. What is the ratio of the Total Labor Force (in %) in Ages 15-20 in 1998 to that in 2000?
Give a very brief answer. 0.89. What is the ratio of the Total Labor Force (in %) in Ages 20-50 in 1998 to that in 2000?
Make the answer very short. 0.9. What is the ratio of the Total Labor Force (in %) of Ages 50+ in 1998 to that in 2000?
Give a very brief answer. 0.9. What is the ratio of the Total Labor Force (in %) in Ages 15-20 in 1998 to that in 2001?
Give a very brief answer. 0.85. What is the ratio of the Total Labor Force (in %) of Ages 20-50 in 1998 to that in 2001?
Provide a short and direct response. 0.85. What is the ratio of the Total Labor Force (in %) in Ages 50+ in 1998 to that in 2001?
Your answer should be very brief. 0.85. What is the ratio of the Total Labor Force (in %) in Ages 15-20 in 1998 to that in 2002?
Your answer should be compact. 0.81. What is the ratio of the Total Labor Force (in %) of Ages 20-50 in 1998 to that in 2002?
Offer a terse response. 0.81. What is the ratio of the Total Labor Force (in %) of Ages 50+ in 1998 to that in 2002?
Provide a short and direct response. 0.81. What is the ratio of the Total Labor Force (in %) in Ages 15-20 in 1998 to that in 2003?
Make the answer very short. 0.77. What is the ratio of the Total Labor Force (in %) in Ages 20-50 in 1998 to that in 2003?
Your answer should be very brief. 0.78. What is the ratio of the Total Labor Force (in %) in Ages 15-20 in 1999 to that in 2000?
Offer a very short reply. 0.95. What is the ratio of the Total Labor Force (in %) of Ages 20-50 in 1999 to that in 2000?
Provide a short and direct response. 0.95. What is the ratio of the Total Labor Force (in %) in Ages 50+ in 1999 to that in 2000?
Provide a short and direct response. 0.95. What is the ratio of the Total Labor Force (in %) in Ages 15-20 in 1999 to that in 2001?
Offer a terse response. 0.9. What is the ratio of the Total Labor Force (in %) in Ages 20-50 in 1999 to that in 2001?
Provide a short and direct response. 0.9. What is the ratio of the Total Labor Force (in %) in Ages 50+ in 1999 to that in 2001?
Provide a succinct answer. 0.9. What is the ratio of the Total Labor Force (in %) of Ages 15-20 in 1999 to that in 2002?
Ensure brevity in your answer.  0.86. What is the ratio of the Total Labor Force (in %) of Ages 20-50 in 1999 to that in 2002?
Give a very brief answer. 0.86. What is the ratio of the Total Labor Force (in %) of Ages 50+ in 1999 to that in 2002?
Your response must be concise. 0.86. What is the ratio of the Total Labor Force (in %) of Ages 15-20 in 1999 to that in 2003?
Your answer should be compact. 0.82. What is the ratio of the Total Labor Force (in %) in Ages 20-50 in 1999 to that in 2003?
Make the answer very short. 0.82. What is the ratio of the Total Labor Force (in %) in Ages 50+ in 1999 to that in 2003?
Make the answer very short. 0.82. What is the ratio of the Total Labor Force (in %) in Ages 15-20 in 2000 to that in 2001?
Offer a very short reply. 0.95. What is the ratio of the Total Labor Force (in %) in Ages 20-50 in 2000 to that in 2001?
Give a very brief answer. 0.95. What is the ratio of the Total Labor Force (in %) in Ages 50+ in 2000 to that in 2001?
Provide a succinct answer. 0.95. What is the ratio of the Total Labor Force (in %) in Ages 15-20 in 2000 to that in 2002?
Provide a short and direct response. 0.9. What is the ratio of the Total Labor Force (in %) of Ages 20-50 in 2000 to that in 2002?
Provide a succinct answer. 0.91. What is the ratio of the Total Labor Force (in %) in Ages 50+ in 2000 to that in 2002?
Ensure brevity in your answer.  0.91. What is the ratio of the Total Labor Force (in %) in Ages 15-20 in 2000 to that in 2003?
Provide a short and direct response. 0.86. What is the ratio of the Total Labor Force (in %) in Ages 20-50 in 2000 to that in 2003?
Ensure brevity in your answer.  0.87. What is the ratio of the Total Labor Force (in %) of Ages 50+ in 2000 to that in 2003?
Your answer should be compact. 0.87. What is the ratio of the Total Labor Force (in %) of Ages 15-20 in 2001 to that in 2002?
Make the answer very short. 0.95. What is the ratio of the Total Labor Force (in %) of Ages 20-50 in 2001 to that in 2002?
Keep it short and to the point. 0.96. What is the ratio of the Total Labor Force (in %) in Ages 50+ in 2001 to that in 2002?
Give a very brief answer. 0.95. What is the ratio of the Total Labor Force (in %) of Ages 15-20 in 2001 to that in 2003?
Ensure brevity in your answer.  0.91. What is the ratio of the Total Labor Force (in %) of Ages 20-50 in 2001 to that in 2003?
Your response must be concise. 0.91. What is the ratio of the Total Labor Force (in %) in Ages 50+ in 2001 to that in 2003?
Your answer should be very brief. 0.91. What is the ratio of the Total Labor Force (in %) in Ages 15-20 in 2002 to that in 2003?
Make the answer very short. 0.96. What is the ratio of the Total Labor Force (in %) of Ages 20-50 in 2002 to that in 2003?
Provide a short and direct response. 0.96. What is the ratio of the Total Labor Force (in %) of Ages 50+ in 2002 to that in 2003?
Make the answer very short. 0.96. What is the difference between the highest and the second highest Total Labor Force (in %) in Ages 15-20?
Provide a short and direct response. 2.1. What is the difference between the highest and the lowest Total Labor Force (in %) in Ages 15-20?
Ensure brevity in your answer.  17. What is the difference between the highest and the lowest Total Labor Force (in %) in Ages 50+?
Make the answer very short. 21.1. 